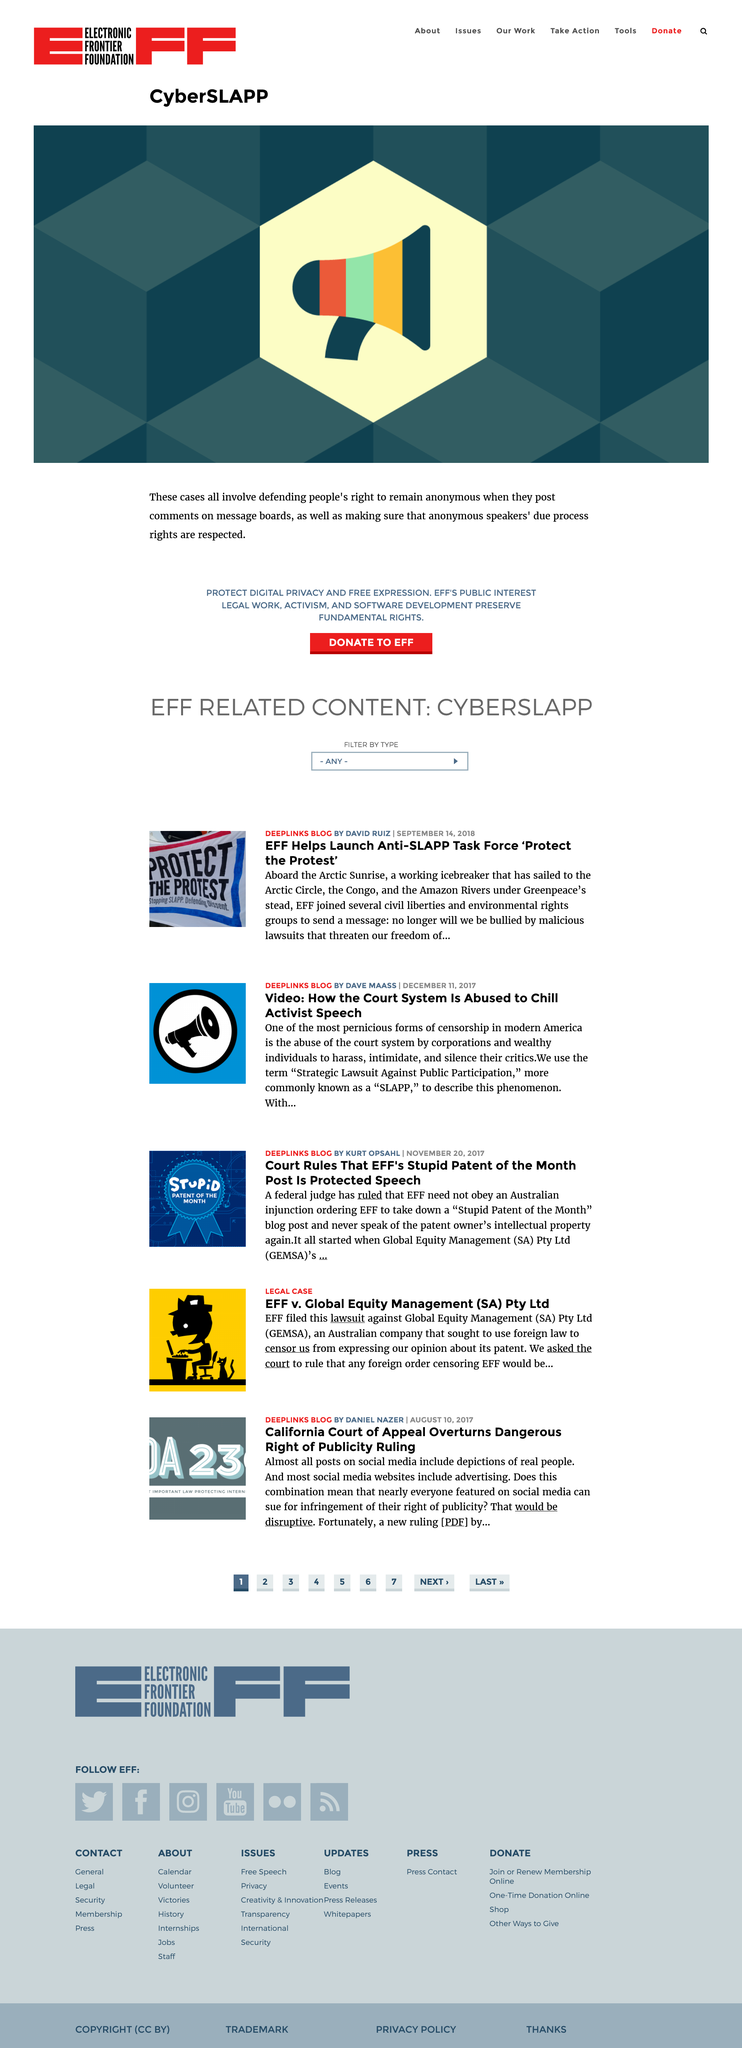Mention a couple of crucial points in this snapshot. Strategic Lawsuit Against Public Participation" is an acronym that is commonly referred to as "SLAPP". It refers to a lawsuit that is brought by a person or organization against someone who has exercised their right to free speech or petition the government for redress of grievances. The first article was written by David Ruiz. The second article was published on December 11, 2017. 